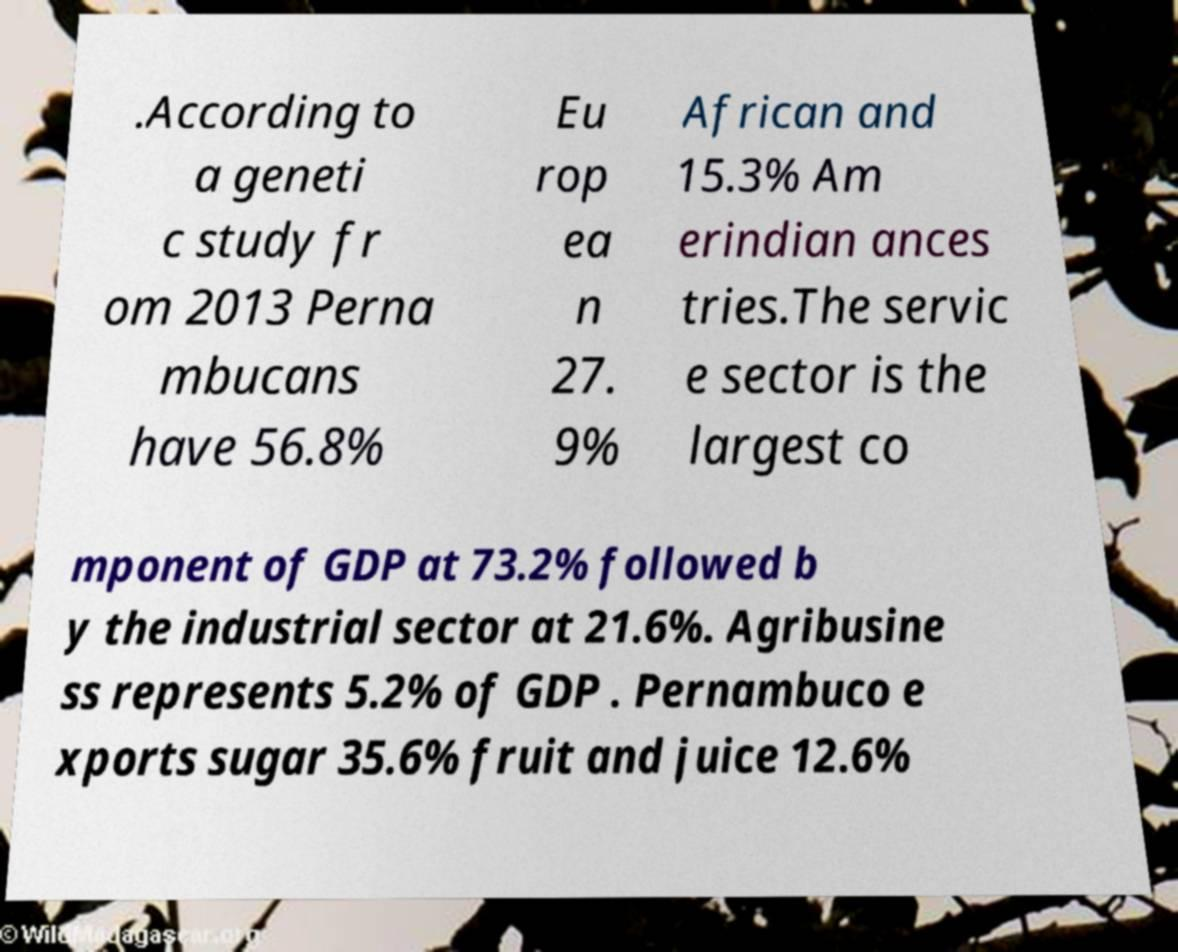I need the written content from this picture converted into text. Can you do that? .According to a geneti c study fr om 2013 Perna mbucans have 56.8% Eu rop ea n 27. 9% African and 15.3% Am erindian ances tries.The servic e sector is the largest co mponent of GDP at 73.2% followed b y the industrial sector at 21.6%. Agribusine ss represents 5.2% of GDP . Pernambuco e xports sugar 35.6% fruit and juice 12.6% 